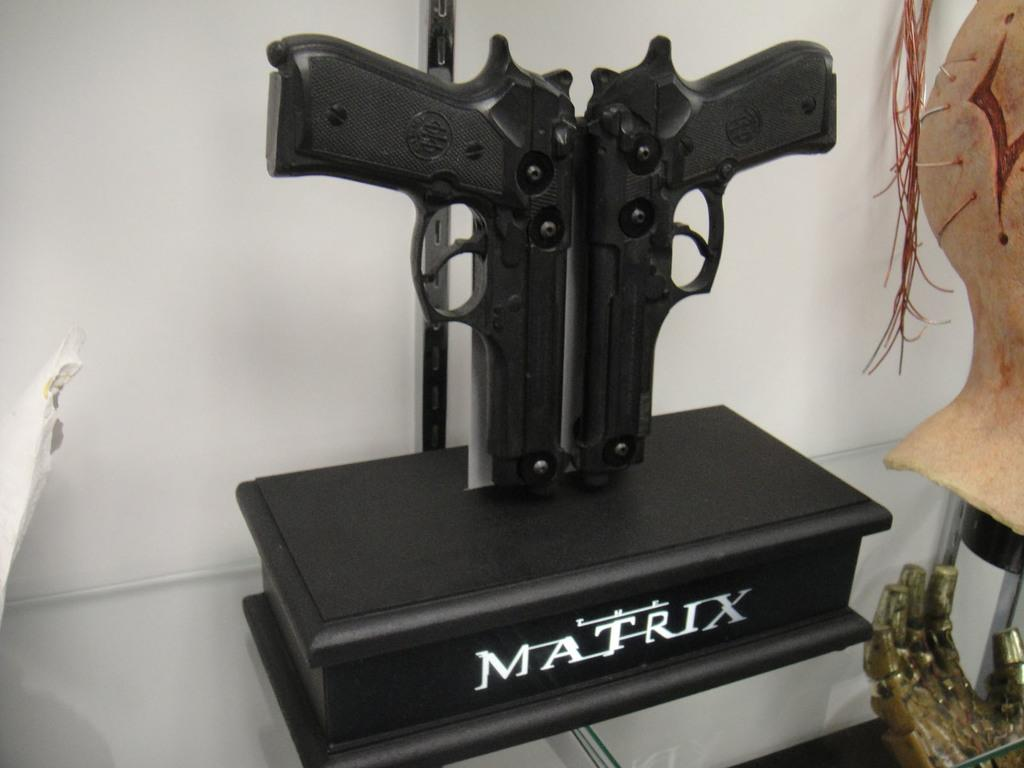What objects are on the box in the image? There are guns on a box in the image. What color is the box? The box is black. What can be seen in the background of the image? There is a wall in the background of the image. What type of objects are to the right of the image? There are objects that look like crafts to the right of the image. What is the title of the book that dad is reading in the hospital in the image? There is no book, dad, or hospital present in the image. 